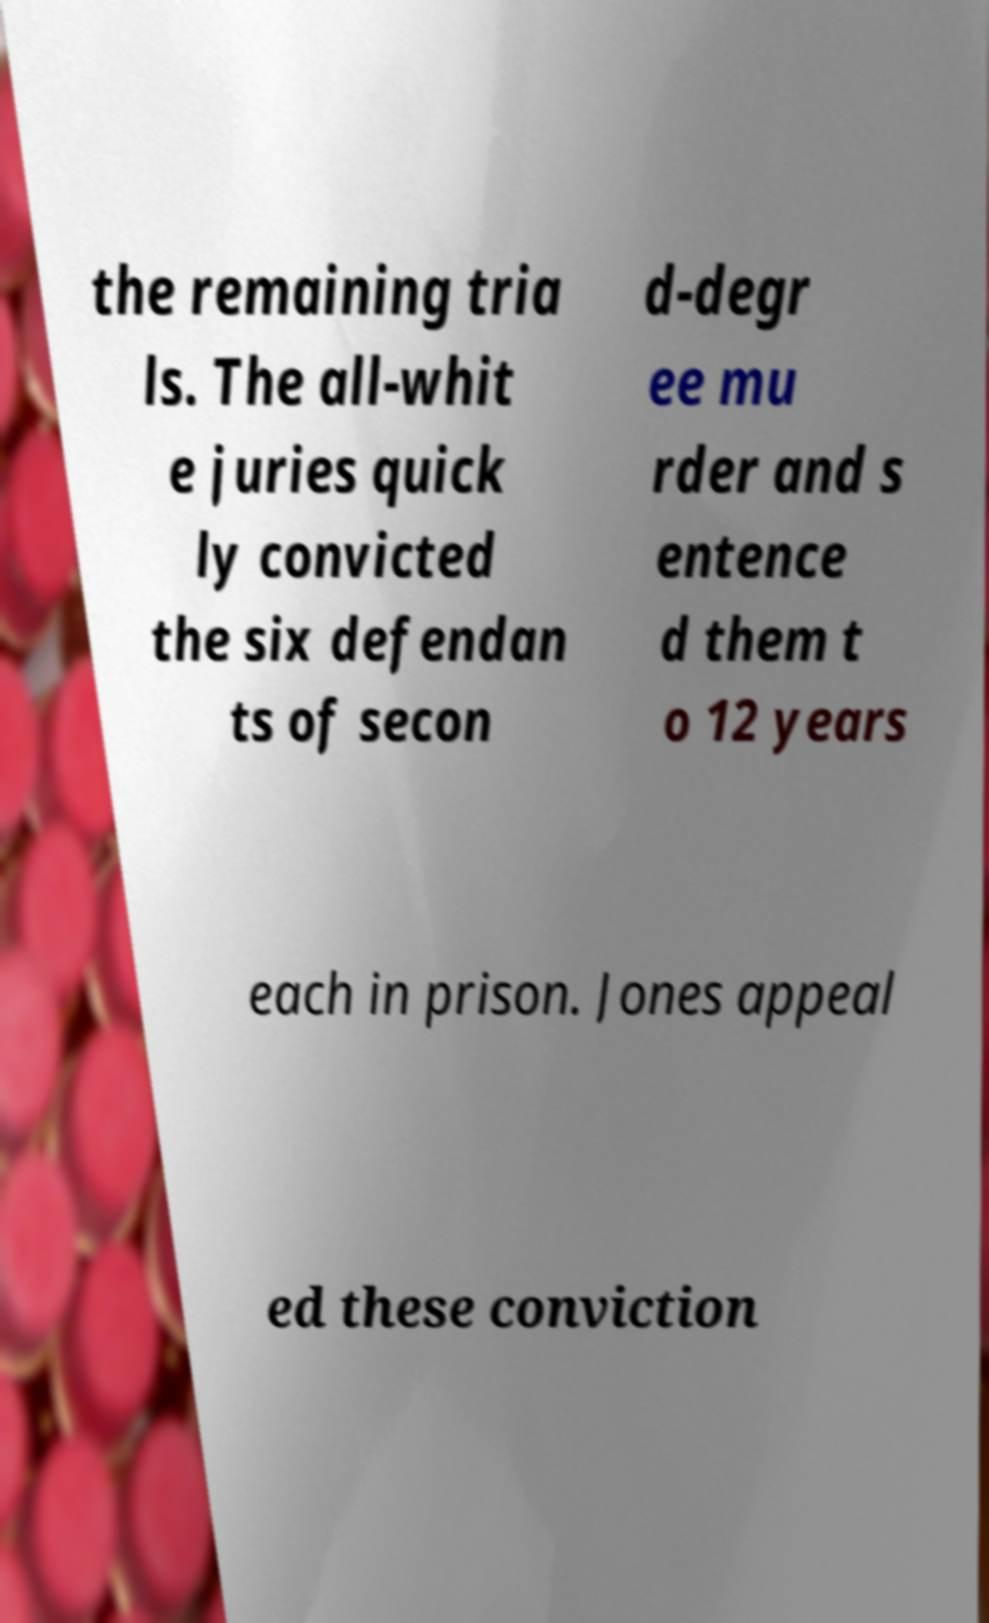What messages or text are displayed in this image? I need them in a readable, typed format. the remaining tria ls. The all-whit e juries quick ly convicted the six defendan ts of secon d-degr ee mu rder and s entence d them t o 12 years each in prison. Jones appeal ed these conviction 